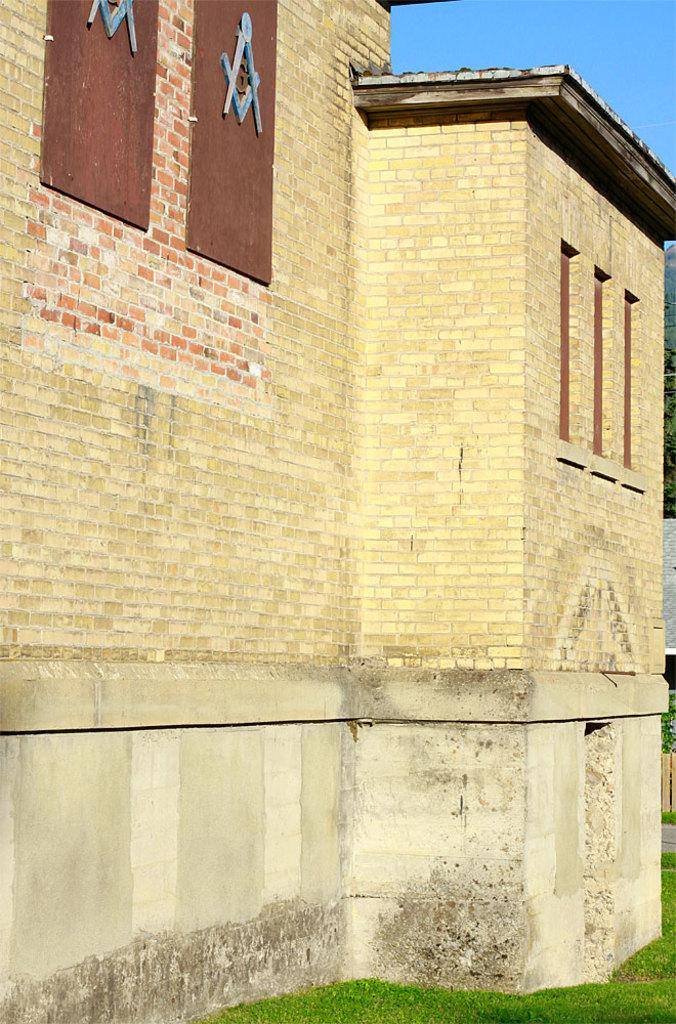What type of structure is present in the image? There is a building in the image. What feature can be seen on the building? The building has windows. What type of natural environment is visible in the image? There is grass visible in the image. What part of the natural environment is visible in the image? The sky is visible in the image. What type of food is being served in the image? There is no food visible in the image. Is there any evidence of a crime occurring in the image? There is no indication of a crime in the image. 